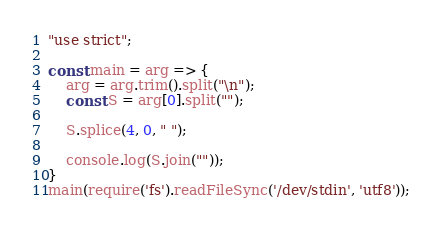<code> <loc_0><loc_0><loc_500><loc_500><_JavaScript_>"use strict";
    
const main = arg => {
    arg = arg.trim().split("\n");
    const S = arg[0].split("");
    
    S.splice(4, 0, " ");
    
    console.log(S.join(""));
}
main(require('fs').readFileSync('/dev/stdin', 'utf8'));</code> 